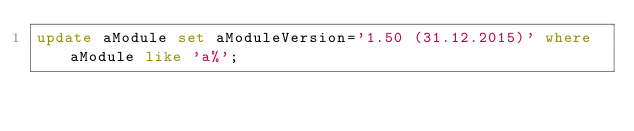<code> <loc_0><loc_0><loc_500><loc_500><_SQL_>update aModule set aModuleVersion='1.50 (31.12.2015)' where aModule like 'a%';
</code> 